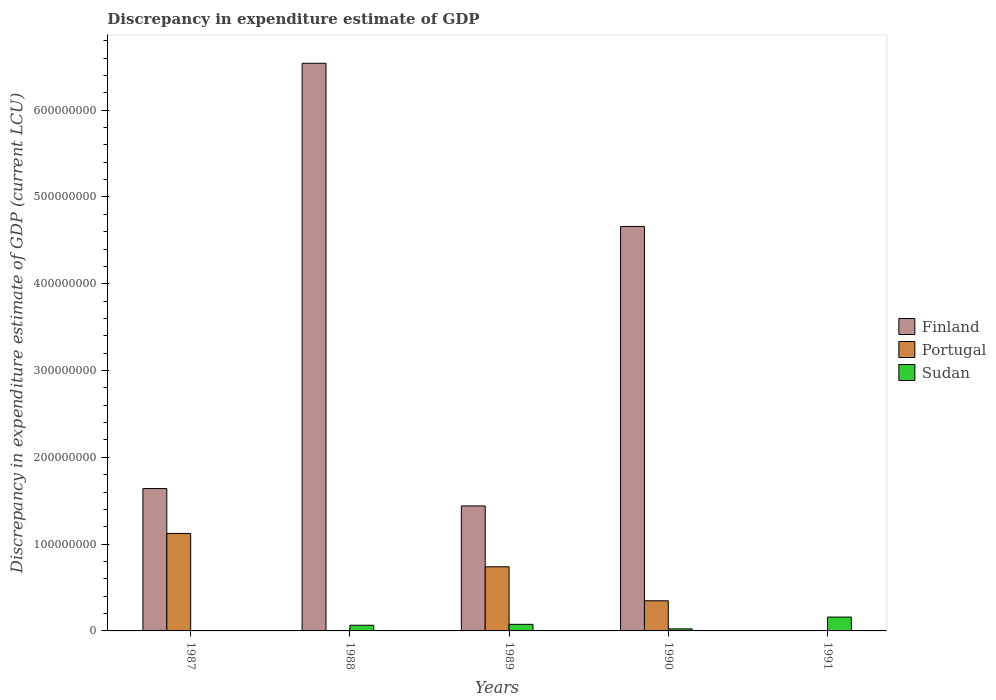How many bars are there on the 5th tick from the right?
Your answer should be compact. 3. What is the label of the 3rd group of bars from the left?
Offer a terse response. 1989. In how many cases, is the number of bars for a given year not equal to the number of legend labels?
Offer a very short reply. 2. What is the discrepancy in expenditure estimate of GDP in Sudan in 1991?
Keep it short and to the point. 1.60e+07. Across all years, what is the maximum discrepancy in expenditure estimate of GDP in Portugal?
Your answer should be very brief. 1.12e+08. Across all years, what is the minimum discrepancy in expenditure estimate of GDP in Portugal?
Your response must be concise. 0. In which year was the discrepancy in expenditure estimate of GDP in Sudan maximum?
Give a very brief answer. 1991. What is the total discrepancy in expenditure estimate of GDP in Finland in the graph?
Ensure brevity in your answer.  1.43e+09. What is the difference between the discrepancy in expenditure estimate of GDP in Portugal in 1987 and that in 1989?
Ensure brevity in your answer.  3.84e+07. What is the difference between the discrepancy in expenditure estimate of GDP in Sudan in 1988 and the discrepancy in expenditure estimate of GDP in Finland in 1987?
Your answer should be very brief. -1.57e+08. What is the average discrepancy in expenditure estimate of GDP in Sudan per year?
Your answer should be compact. 6.49e+06. In the year 1988, what is the difference between the discrepancy in expenditure estimate of GDP in Sudan and discrepancy in expenditure estimate of GDP in Finland?
Ensure brevity in your answer.  -6.47e+08. What is the ratio of the discrepancy in expenditure estimate of GDP in Finland in 1989 to that in 1990?
Provide a short and direct response. 0.31. Is the discrepancy in expenditure estimate of GDP in Portugal in 1989 less than that in 1990?
Your answer should be very brief. No. Is the difference between the discrepancy in expenditure estimate of GDP in Sudan in 1988 and 1989 greater than the difference between the discrepancy in expenditure estimate of GDP in Finland in 1988 and 1989?
Give a very brief answer. No. What is the difference between the highest and the second highest discrepancy in expenditure estimate of GDP in Finland?
Make the answer very short. 1.88e+08. What is the difference between the highest and the lowest discrepancy in expenditure estimate of GDP in Sudan?
Your response must be concise. 1.59e+07. In how many years, is the discrepancy in expenditure estimate of GDP in Finland greater than the average discrepancy in expenditure estimate of GDP in Finland taken over all years?
Offer a very short reply. 2. Is it the case that in every year, the sum of the discrepancy in expenditure estimate of GDP in Sudan and discrepancy in expenditure estimate of GDP in Portugal is greater than the discrepancy in expenditure estimate of GDP in Finland?
Your answer should be very brief. No. Are all the bars in the graph horizontal?
Ensure brevity in your answer.  No. Are the values on the major ticks of Y-axis written in scientific E-notation?
Provide a succinct answer. No. Does the graph contain any zero values?
Offer a terse response. Yes. Does the graph contain grids?
Keep it short and to the point. No. How many legend labels are there?
Your response must be concise. 3. What is the title of the graph?
Your answer should be compact. Discrepancy in expenditure estimate of GDP. Does "United Kingdom" appear as one of the legend labels in the graph?
Provide a succinct answer. No. What is the label or title of the X-axis?
Your response must be concise. Years. What is the label or title of the Y-axis?
Ensure brevity in your answer.  Discrepancy in expenditure estimate of GDP (current LCU). What is the Discrepancy in expenditure estimate of GDP (current LCU) in Finland in 1987?
Offer a terse response. 1.64e+08. What is the Discrepancy in expenditure estimate of GDP (current LCU) of Portugal in 1987?
Give a very brief answer. 1.12e+08. What is the Discrepancy in expenditure estimate of GDP (current LCU) in Sudan in 1987?
Provide a short and direct response. 1000. What is the Discrepancy in expenditure estimate of GDP (current LCU) in Finland in 1988?
Your answer should be very brief. 6.54e+08. What is the Discrepancy in expenditure estimate of GDP (current LCU) in Portugal in 1988?
Ensure brevity in your answer.  0. What is the Discrepancy in expenditure estimate of GDP (current LCU) in Sudan in 1988?
Offer a terse response. 6.55e+06. What is the Discrepancy in expenditure estimate of GDP (current LCU) of Finland in 1989?
Keep it short and to the point. 1.44e+08. What is the Discrepancy in expenditure estimate of GDP (current LCU) in Portugal in 1989?
Your answer should be compact. 7.39e+07. What is the Discrepancy in expenditure estimate of GDP (current LCU) in Sudan in 1989?
Provide a succinct answer. 7.59e+06. What is the Discrepancy in expenditure estimate of GDP (current LCU) of Finland in 1990?
Offer a terse response. 4.66e+08. What is the Discrepancy in expenditure estimate of GDP (current LCU) in Portugal in 1990?
Offer a very short reply. 3.47e+07. What is the Discrepancy in expenditure estimate of GDP (current LCU) in Sudan in 1990?
Your answer should be compact. 2.34e+06. What is the Discrepancy in expenditure estimate of GDP (current LCU) in Sudan in 1991?
Provide a short and direct response. 1.60e+07. Across all years, what is the maximum Discrepancy in expenditure estimate of GDP (current LCU) in Finland?
Give a very brief answer. 6.54e+08. Across all years, what is the maximum Discrepancy in expenditure estimate of GDP (current LCU) in Portugal?
Your answer should be very brief. 1.12e+08. Across all years, what is the maximum Discrepancy in expenditure estimate of GDP (current LCU) of Sudan?
Keep it short and to the point. 1.60e+07. Across all years, what is the minimum Discrepancy in expenditure estimate of GDP (current LCU) of Finland?
Ensure brevity in your answer.  0. Across all years, what is the minimum Discrepancy in expenditure estimate of GDP (current LCU) in Sudan?
Keep it short and to the point. 1000. What is the total Discrepancy in expenditure estimate of GDP (current LCU) of Finland in the graph?
Your response must be concise. 1.43e+09. What is the total Discrepancy in expenditure estimate of GDP (current LCU) in Portugal in the graph?
Keep it short and to the point. 2.21e+08. What is the total Discrepancy in expenditure estimate of GDP (current LCU) in Sudan in the graph?
Ensure brevity in your answer.  3.24e+07. What is the difference between the Discrepancy in expenditure estimate of GDP (current LCU) of Finland in 1987 and that in 1988?
Keep it short and to the point. -4.90e+08. What is the difference between the Discrepancy in expenditure estimate of GDP (current LCU) of Sudan in 1987 and that in 1988?
Your answer should be compact. -6.55e+06. What is the difference between the Discrepancy in expenditure estimate of GDP (current LCU) in Portugal in 1987 and that in 1989?
Your answer should be very brief. 3.84e+07. What is the difference between the Discrepancy in expenditure estimate of GDP (current LCU) in Sudan in 1987 and that in 1989?
Offer a terse response. -7.59e+06. What is the difference between the Discrepancy in expenditure estimate of GDP (current LCU) of Finland in 1987 and that in 1990?
Keep it short and to the point. -3.02e+08. What is the difference between the Discrepancy in expenditure estimate of GDP (current LCU) of Portugal in 1987 and that in 1990?
Make the answer very short. 7.76e+07. What is the difference between the Discrepancy in expenditure estimate of GDP (current LCU) of Sudan in 1987 and that in 1990?
Keep it short and to the point. -2.34e+06. What is the difference between the Discrepancy in expenditure estimate of GDP (current LCU) in Sudan in 1987 and that in 1991?
Keep it short and to the point. -1.60e+07. What is the difference between the Discrepancy in expenditure estimate of GDP (current LCU) of Finland in 1988 and that in 1989?
Give a very brief answer. 5.10e+08. What is the difference between the Discrepancy in expenditure estimate of GDP (current LCU) of Sudan in 1988 and that in 1989?
Offer a very short reply. -1.05e+06. What is the difference between the Discrepancy in expenditure estimate of GDP (current LCU) of Finland in 1988 and that in 1990?
Your response must be concise. 1.88e+08. What is the difference between the Discrepancy in expenditure estimate of GDP (current LCU) in Sudan in 1988 and that in 1990?
Give a very brief answer. 4.20e+06. What is the difference between the Discrepancy in expenditure estimate of GDP (current LCU) of Sudan in 1988 and that in 1991?
Provide a short and direct response. -9.40e+06. What is the difference between the Discrepancy in expenditure estimate of GDP (current LCU) of Finland in 1989 and that in 1990?
Provide a short and direct response. -3.22e+08. What is the difference between the Discrepancy in expenditure estimate of GDP (current LCU) of Portugal in 1989 and that in 1990?
Provide a succinct answer. 3.92e+07. What is the difference between the Discrepancy in expenditure estimate of GDP (current LCU) in Sudan in 1989 and that in 1990?
Give a very brief answer. 5.25e+06. What is the difference between the Discrepancy in expenditure estimate of GDP (current LCU) in Sudan in 1989 and that in 1991?
Offer a very short reply. -8.36e+06. What is the difference between the Discrepancy in expenditure estimate of GDP (current LCU) of Sudan in 1990 and that in 1991?
Keep it short and to the point. -1.36e+07. What is the difference between the Discrepancy in expenditure estimate of GDP (current LCU) in Finland in 1987 and the Discrepancy in expenditure estimate of GDP (current LCU) in Sudan in 1988?
Offer a terse response. 1.57e+08. What is the difference between the Discrepancy in expenditure estimate of GDP (current LCU) of Portugal in 1987 and the Discrepancy in expenditure estimate of GDP (current LCU) of Sudan in 1988?
Your response must be concise. 1.06e+08. What is the difference between the Discrepancy in expenditure estimate of GDP (current LCU) of Finland in 1987 and the Discrepancy in expenditure estimate of GDP (current LCU) of Portugal in 1989?
Make the answer very short. 9.01e+07. What is the difference between the Discrepancy in expenditure estimate of GDP (current LCU) in Finland in 1987 and the Discrepancy in expenditure estimate of GDP (current LCU) in Sudan in 1989?
Make the answer very short. 1.56e+08. What is the difference between the Discrepancy in expenditure estimate of GDP (current LCU) in Portugal in 1987 and the Discrepancy in expenditure estimate of GDP (current LCU) in Sudan in 1989?
Offer a very short reply. 1.05e+08. What is the difference between the Discrepancy in expenditure estimate of GDP (current LCU) in Finland in 1987 and the Discrepancy in expenditure estimate of GDP (current LCU) in Portugal in 1990?
Your answer should be very brief. 1.29e+08. What is the difference between the Discrepancy in expenditure estimate of GDP (current LCU) in Finland in 1987 and the Discrepancy in expenditure estimate of GDP (current LCU) in Sudan in 1990?
Keep it short and to the point. 1.62e+08. What is the difference between the Discrepancy in expenditure estimate of GDP (current LCU) in Portugal in 1987 and the Discrepancy in expenditure estimate of GDP (current LCU) in Sudan in 1990?
Make the answer very short. 1.10e+08. What is the difference between the Discrepancy in expenditure estimate of GDP (current LCU) in Finland in 1987 and the Discrepancy in expenditure estimate of GDP (current LCU) in Sudan in 1991?
Make the answer very short. 1.48e+08. What is the difference between the Discrepancy in expenditure estimate of GDP (current LCU) of Portugal in 1987 and the Discrepancy in expenditure estimate of GDP (current LCU) of Sudan in 1991?
Give a very brief answer. 9.64e+07. What is the difference between the Discrepancy in expenditure estimate of GDP (current LCU) of Finland in 1988 and the Discrepancy in expenditure estimate of GDP (current LCU) of Portugal in 1989?
Provide a short and direct response. 5.80e+08. What is the difference between the Discrepancy in expenditure estimate of GDP (current LCU) of Finland in 1988 and the Discrepancy in expenditure estimate of GDP (current LCU) of Sudan in 1989?
Your answer should be compact. 6.46e+08. What is the difference between the Discrepancy in expenditure estimate of GDP (current LCU) of Finland in 1988 and the Discrepancy in expenditure estimate of GDP (current LCU) of Portugal in 1990?
Offer a terse response. 6.19e+08. What is the difference between the Discrepancy in expenditure estimate of GDP (current LCU) in Finland in 1988 and the Discrepancy in expenditure estimate of GDP (current LCU) in Sudan in 1990?
Provide a succinct answer. 6.52e+08. What is the difference between the Discrepancy in expenditure estimate of GDP (current LCU) of Finland in 1988 and the Discrepancy in expenditure estimate of GDP (current LCU) of Sudan in 1991?
Your response must be concise. 6.38e+08. What is the difference between the Discrepancy in expenditure estimate of GDP (current LCU) in Finland in 1989 and the Discrepancy in expenditure estimate of GDP (current LCU) in Portugal in 1990?
Give a very brief answer. 1.09e+08. What is the difference between the Discrepancy in expenditure estimate of GDP (current LCU) in Finland in 1989 and the Discrepancy in expenditure estimate of GDP (current LCU) in Sudan in 1990?
Keep it short and to the point. 1.42e+08. What is the difference between the Discrepancy in expenditure estimate of GDP (current LCU) of Portugal in 1989 and the Discrepancy in expenditure estimate of GDP (current LCU) of Sudan in 1990?
Your answer should be compact. 7.15e+07. What is the difference between the Discrepancy in expenditure estimate of GDP (current LCU) of Finland in 1989 and the Discrepancy in expenditure estimate of GDP (current LCU) of Sudan in 1991?
Make the answer very short. 1.28e+08. What is the difference between the Discrepancy in expenditure estimate of GDP (current LCU) in Portugal in 1989 and the Discrepancy in expenditure estimate of GDP (current LCU) in Sudan in 1991?
Provide a short and direct response. 5.79e+07. What is the difference between the Discrepancy in expenditure estimate of GDP (current LCU) in Finland in 1990 and the Discrepancy in expenditure estimate of GDP (current LCU) in Sudan in 1991?
Make the answer very short. 4.50e+08. What is the difference between the Discrepancy in expenditure estimate of GDP (current LCU) of Portugal in 1990 and the Discrepancy in expenditure estimate of GDP (current LCU) of Sudan in 1991?
Your answer should be very brief. 1.88e+07. What is the average Discrepancy in expenditure estimate of GDP (current LCU) in Finland per year?
Provide a short and direct response. 2.86e+08. What is the average Discrepancy in expenditure estimate of GDP (current LCU) in Portugal per year?
Offer a terse response. 4.42e+07. What is the average Discrepancy in expenditure estimate of GDP (current LCU) of Sudan per year?
Provide a succinct answer. 6.49e+06. In the year 1987, what is the difference between the Discrepancy in expenditure estimate of GDP (current LCU) in Finland and Discrepancy in expenditure estimate of GDP (current LCU) in Portugal?
Provide a succinct answer. 5.17e+07. In the year 1987, what is the difference between the Discrepancy in expenditure estimate of GDP (current LCU) of Finland and Discrepancy in expenditure estimate of GDP (current LCU) of Sudan?
Offer a terse response. 1.64e+08. In the year 1987, what is the difference between the Discrepancy in expenditure estimate of GDP (current LCU) in Portugal and Discrepancy in expenditure estimate of GDP (current LCU) in Sudan?
Your response must be concise. 1.12e+08. In the year 1988, what is the difference between the Discrepancy in expenditure estimate of GDP (current LCU) in Finland and Discrepancy in expenditure estimate of GDP (current LCU) in Sudan?
Provide a succinct answer. 6.47e+08. In the year 1989, what is the difference between the Discrepancy in expenditure estimate of GDP (current LCU) in Finland and Discrepancy in expenditure estimate of GDP (current LCU) in Portugal?
Your answer should be compact. 7.01e+07. In the year 1989, what is the difference between the Discrepancy in expenditure estimate of GDP (current LCU) of Finland and Discrepancy in expenditure estimate of GDP (current LCU) of Sudan?
Provide a short and direct response. 1.36e+08. In the year 1989, what is the difference between the Discrepancy in expenditure estimate of GDP (current LCU) in Portugal and Discrepancy in expenditure estimate of GDP (current LCU) in Sudan?
Give a very brief answer. 6.63e+07. In the year 1990, what is the difference between the Discrepancy in expenditure estimate of GDP (current LCU) in Finland and Discrepancy in expenditure estimate of GDP (current LCU) in Portugal?
Offer a terse response. 4.31e+08. In the year 1990, what is the difference between the Discrepancy in expenditure estimate of GDP (current LCU) in Finland and Discrepancy in expenditure estimate of GDP (current LCU) in Sudan?
Provide a succinct answer. 4.64e+08. In the year 1990, what is the difference between the Discrepancy in expenditure estimate of GDP (current LCU) of Portugal and Discrepancy in expenditure estimate of GDP (current LCU) of Sudan?
Your response must be concise. 3.24e+07. What is the ratio of the Discrepancy in expenditure estimate of GDP (current LCU) in Finland in 1987 to that in 1988?
Provide a short and direct response. 0.25. What is the ratio of the Discrepancy in expenditure estimate of GDP (current LCU) in Finland in 1987 to that in 1989?
Keep it short and to the point. 1.14. What is the ratio of the Discrepancy in expenditure estimate of GDP (current LCU) in Portugal in 1987 to that in 1989?
Ensure brevity in your answer.  1.52. What is the ratio of the Discrepancy in expenditure estimate of GDP (current LCU) of Sudan in 1987 to that in 1989?
Your answer should be very brief. 0. What is the ratio of the Discrepancy in expenditure estimate of GDP (current LCU) in Finland in 1987 to that in 1990?
Your answer should be very brief. 0.35. What is the ratio of the Discrepancy in expenditure estimate of GDP (current LCU) of Portugal in 1987 to that in 1990?
Provide a succinct answer. 3.23. What is the ratio of the Discrepancy in expenditure estimate of GDP (current LCU) in Sudan in 1987 to that in 1990?
Make the answer very short. 0. What is the ratio of the Discrepancy in expenditure estimate of GDP (current LCU) of Sudan in 1987 to that in 1991?
Your answer should be compact. 0. What is the ratio of the Discrepancy in expenditure estimate of GDP (current LCU) in Finland in 1988 to that in 1989?
Your response must be concise. 4.54. What is the ratio of the Discrepancy in expenditure estimate of GDP (current LCU) in Sudan in 1988 to that in 1989?
Provide a short and direct response. 0.86. What is the ratio of the Discrepancy in expenditure estimate of GDP (current LCU) in Finland in 1988 to that in 1990?
Your answer should be compact. 1.4. What is the ratio of the Discrepancy in expenditure estimate of GDP (current LCU) in Sudan in 1988 to that in 1990?
Offer a terse response. 2.79. What is the ratio of the Discrepancy in expenditure estimate of GDP (current LCU) in Sudan in 1988 to that in 1991?
Your response must be concise. 0.41. What is the ratio of the Discrepancy in expenditure estimate of GDP (current LCU) in Finland in 1989 to that in 1990?
Give a very brief answer. 0.31. What is the ratio of the Discrepancy in expenditure estimate of GDP (current LCU) in Portugal in 1989 to that in 1990?
Provide a succinct answer. 2.13. What is the ratio of the Discrepancy in expenditure estimate of GDP (current LCU) of Sudan in 1989 to that in 1990?
Offer a terse response. 3.24. What is the ratio of the Discrepancy in expenditure estimate of GDP (current LCU) in Sudan in 1989 to that in 1991?
Your response must be concise. 0.48. What is the ratio of the Discrepancy in expenditure estimate of GDP (current LCU) of Sudan in 1990 to that in 1991?
Keep it short and to the point. 0.15. What is the difference between the highest and the second highest Discrepancy in expenditure estimate of GDP (current LCU) of Finland?
Your response must be concise. 1.88e+08. What is the difference between the highest and the second highest Discrepancy in expenditure estimate of GDP (current LCU) in Portugal?
Your answer should be very brief. 3.84e+07. What is the difference between the highest and the second highest Discrepancy in expenditure estimate of GDP (current LCU) in Sudan?
Offer a terse response. 8.36e+06. What is the difference between the highest and the lowest Discrepancy in expenditure estimate of GDP (current LCU) of Finland?
Your answer should be compact. 6.54e+08. What is the difference between the highest and the lowest Discrepancy in expenditure estimate of GDP (current LCU) of Portugal?
Your response must be concise. 1.12e+08. What is the difference between the highest and the lowest Discrepancy in expenditure estimate of GDP (current LCU) in Sudan?
Your response must be concise. 1.60e+07. 